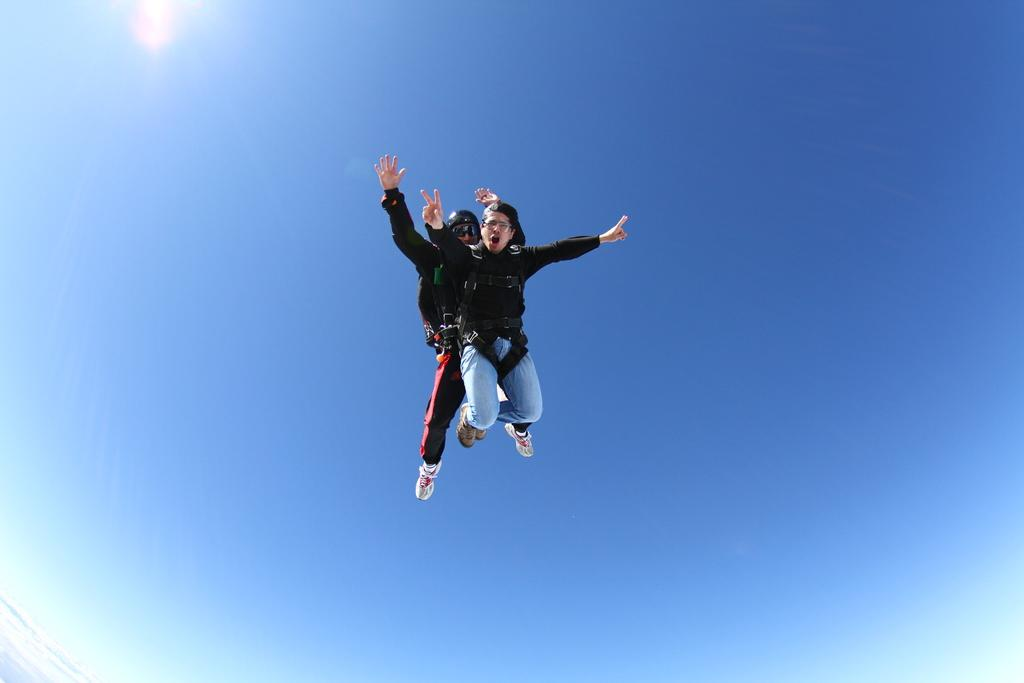How many people are in the image? There are two people in the air. What is the background of the image? The sky is visible behind the people. How many bombs can be seen in the image? There are no bombs present in the image. What type of beast is visible in the image? There is no beast present in the image. 